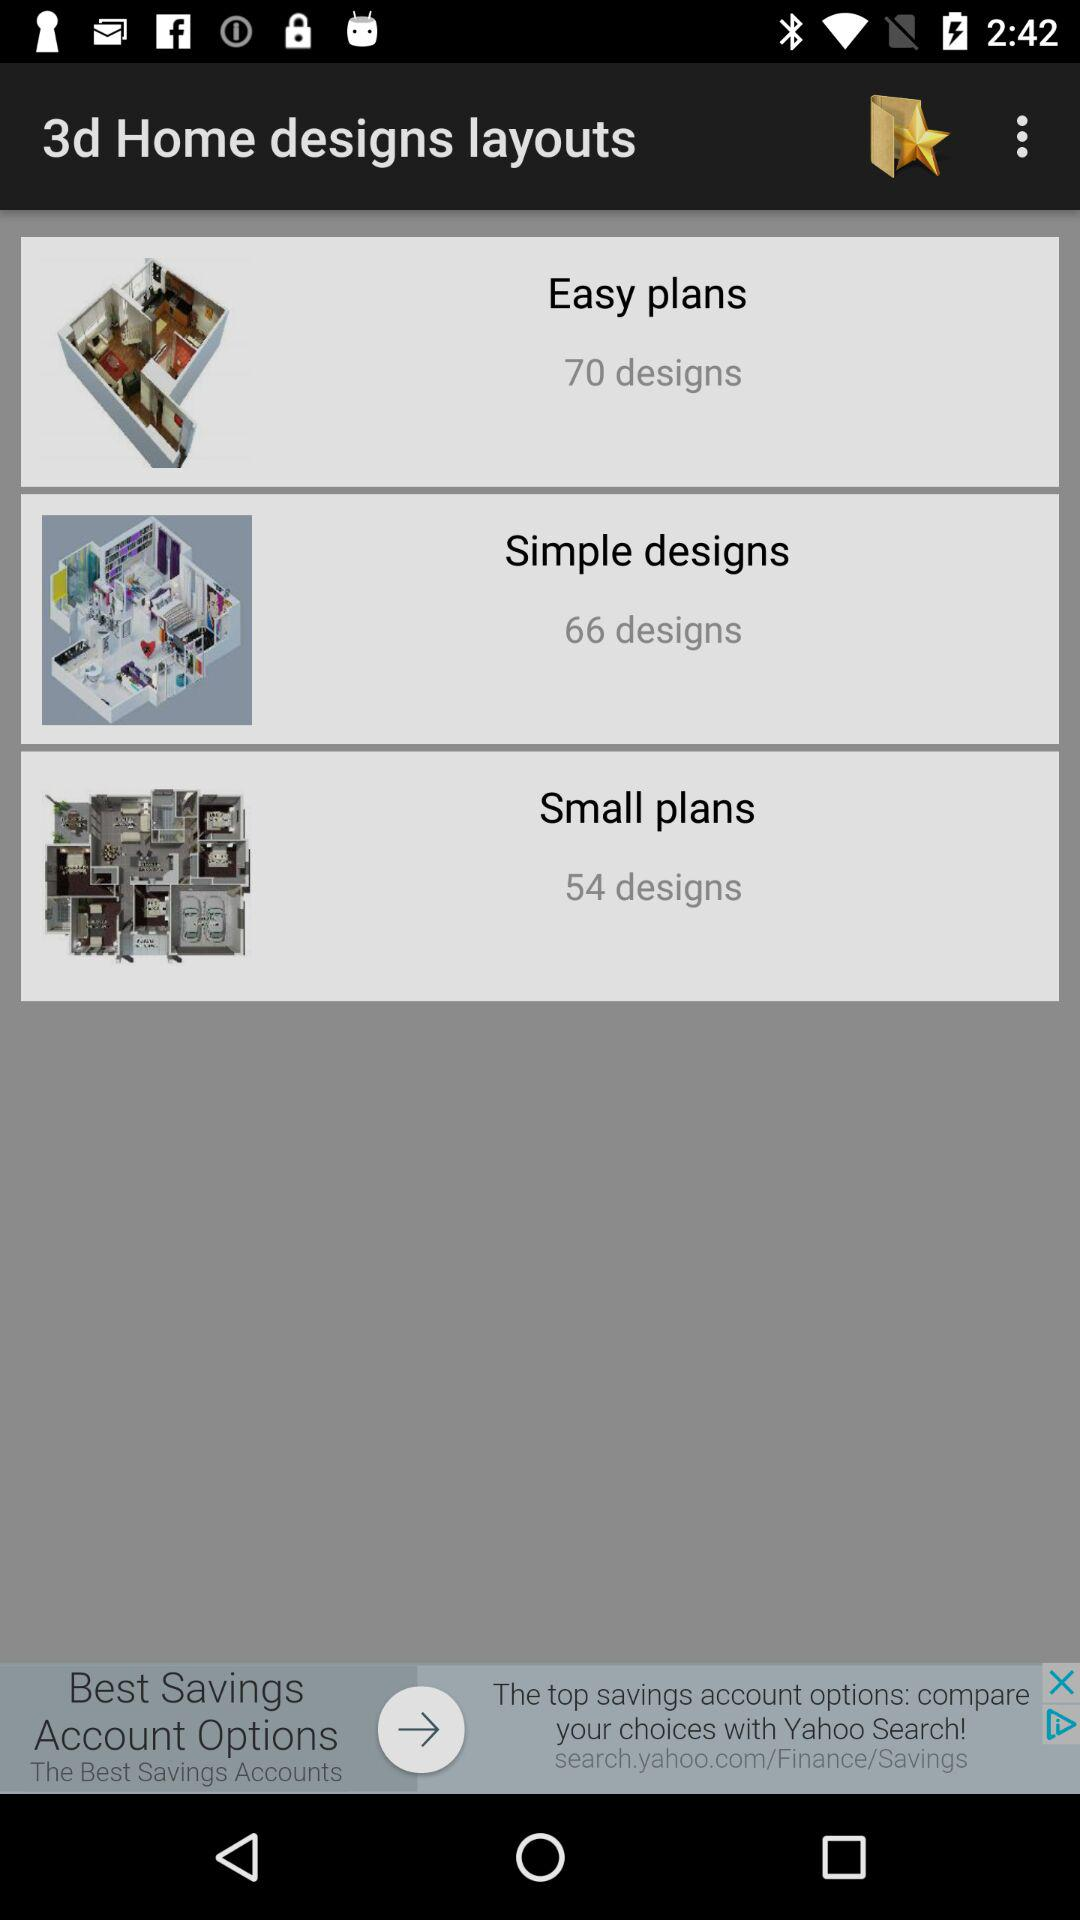Which layouts have 66 designs? The layout that has 66 designs is "Simple designs". 